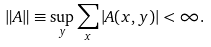<formula> <loc_0><loc_0><loc_500><loc_500>\| A \| \equiv \sup _ { y } \sum _ { x } | A ( x , y ) | < \infty .</formula> 